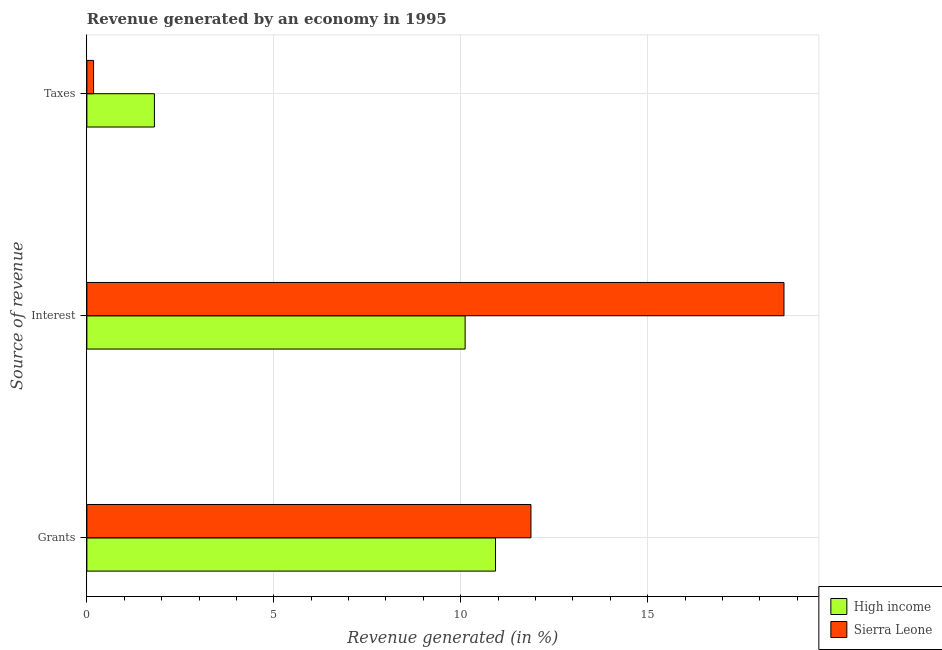How many bars are there on the 3rd tick from the bottom?
Provide a short and direct response. 2. What is the label of the 3rd group of bars from the top?
Provide a succinct answer. Grants. What is the percentage of revenue generated by taxes in High income?
Offer a very short reply. 1.81. Across all countries, what is the maximum percentage of revenue generated by taxes?
Provide a succinct answer. 1.81. Across all countries, what is the minimum percentage of revenue generated by grants?
Give a very brief answer. 10.93. In which country was the percentage of revenue generated by grants maximum?
Make the answer very short. Sierra Leone. In which country was the percentage of revenue generated by grants minimum?
Give a very brief answer. High income. What is the total percentage of revenue generated by taxes in the graph?
Ensure brevity in your answer.  1.99. What is the difference between the percentage of revenue generated by grants in High income and that in Sierra Leone?
Give a very brief answer. -0.95. What is the difference between the percentage of revenue generated by grants in High income and the percentage of revenue generated by interest in Sierra Leone?
Make the answer very short. -7.72. What is the average percentage of revenue generated by taxes per country?
Give a very brief answer. 0.99. What is the difference between the percentage of revenue generated by taxes and percentage of revenue generated by grants in Sierra Leone?
Provide a short and direct response. -11.7. What is the ratio of the percentage of revenue generated by interest in High income to that in Sierra Leone?
Make the answer very short. 0.54. What is the difference between the highest and the second highest percentage of revenue generated by taxes?
Offer a terse response. 1.63. What is the difference between the highest and the lowest percentage of revenue generated by grants?
Your answer should be very brief. 0.95. Is the sum of the percentage of revenue generated by grants in High income and Sierra Leone greater than the maximum percentage of revenue generated by interest across all countries?
Ensure brevity in your answer.  Yes. What does the 1st bar from the top in Grants represents?
Your response must be concise. Sierra Leone. Is it the case that in every country, the sum of the percentage of revenue generated by grants and percentage of revenue generated by interest is greater than the percentage of revenue generated by taxes?
Your answer should be very brief. Yes. How many bars are there?
Offer a very short reply. 6. Are all the bars in the graph horizontal?
Offer a very short reply. Yes. How many countries are there in the graph?
Keep it short and to the point. 2. Are the values on the major ticks of X-axis written in scientific E-notation?
Keep it short and to the point. No. Does the graph contain any zero values?
Your answer should be very brief. No. How many legend labels are there?
Your response must be concise. 2. What is the title of the graph?
Ensure brevity in your answer.  Revenue generated by an economy in 1995. Does "Liechtenstein" appear as one of the legend labels in the graph?
Provide a short and direct response. No. What is the label or title of the X-axis?
Your answer should be very brief. Revenue generated (in %). What is the label or title of the Y-axis?
Your answer should be very brief. Source of revenue. What is the Revenue generated (in %) of High income in Grants?
Make the answer very short. 10.93. What is the Revenue generated (in %) in Sierra Leone in Grants?
Your response must be concise. 11.88. What is the Revenue generated (in %) of High income in Interest?
Keep it short and to the point. 10.12. What is the Revenue generated (in %) of Sierra Leone in Interest?
Offer a very short reply. 18.65. What is the Revenue generated (in %) in High income in Taxes?
Make the answer very short. 1.81. What is the Revenue generated (in %) of Sierra Leone in Taxes?
Your response must be concise. 0.18. Across all Source of revenue, what is the maximum Revenue generated (in %) in High income?
Offer a very short reply. 10.93. Across all Source of revenue, what is the maximum Revenue generated (in %) in Sierra Leone?
Keep it short and to the point. 18.65. Across all Source of revenue, what is the minimum Revenue generated (in %) of High income?
Your answer should be compact. 1.81. Across all Source of revenue, what is the minimum Revenue generated (in %) in Sierra Leone?
Offer a very short reply. 0.18. What is the total Revenue generated (in %) in High income in the graph?
Your answer should be very brief. 22.85. What is the total Revenue generated (in %) in Sierra Leone in the graph?
Keep it short and to the point. 30.7. What is the difference between the Revenue generated (in %) in High income in Grants and that in Interest?
Ensure brevity in your answer.  0.81. What is the difference between the Revenue generated (in %) of Sierra Leone in Grants and that in Interest?
Offer a very short reply. -6.77. What is the difference between the Revenue generated (in %) of High income in Grants and that in Taxes?
Your answer should be compact. 9.12. What is the difference between the Revenue generated (in %) in Sierra Leone in Grants and that in Taxes?
Provide a succinct answer. 11.7. What is the difference between the Revenue generated (in %) in High income in Interest and that in Taxes?
Your response must be concise. 8.31. What is the difference between the Revenue generated (in %) in Sierra Leone in Interest and that in Taxes?
Offer a very short reply. 18.47. What is the difference between the Revenue generated (in %) in High income in Grants and the Revenue generated (in %) in Sierra Leone in Interest?
Your response must be concise. -7.72. What is the difference between the Revenue generated (in %) in High income in Grants and the Revenue generated (in %) in Sierra Leone in Taxes?
Keep it short and to the point. 10.75. What is the difference between the Revenue generated (in %) in High income in Interest and the Revenue generated (in %) in Sierra Leone in Taxes?
Make the answer very short. 9.94. What is the average Revenue generated (in %) in High income per Source of revenue?
Your answer should be very brief. 7.62. What is the average Revenue generated (in %) of Sierra Leone per Source of revenue?
Offer a terse response. 10.23. What is the difference between the Revenue generated (in %) of High income and Revenue generated (in %) of Sierra Leone in Grants?
Your response must be concise. -0.95. What is the difference between the Revenue generated (in %) in High income and Revenue generated (in %) in Sierra Leone in Interest?
Offer a very short reply. -8.53. What is the difference between the Revenue generated (in %) in High income and Revenue generated (in %) in Sierra Leone in Taxes?
Provide a short and direct response. 1.63. What is the ratio of the Revenue generated (in %) in High income in Grants to that in Interest?
Ensure brevity in your answer.  1.08. What is the ratio of the Revenue generated (in %) of Sierra Leone in Grants to that in Interest?
Make the answer very short. 0.64. What is the ratio of the Revenue generated (in %) in High income in Grants to that in Taxes?
Provide a succinct answer. 6.05. What is the ratio of the Revenue generated (in %) of Sierra Leone in Grants to that in Taxes?
Provide a short and direct response. 66.24. What is the ratio of the Revenue generated (in %) of High income in Interest to that in Taxes?
Offer a terse response. 5.6. What is the ratio of the Revenue generated (in %) in Sierra Leone in Interest to that in Taxes?
Keep it short and to the point. 103.98. What is the difference between the highest and the second highest Revenue generated (in %) of High income?
Provide a short and direct response. 0.81. What is the difference between the highest and the second highest Revenue generated (in %) of Sierra Leone?
Your response must be concise. 6.77. What is the difference between the highest and the lowest Revenue generated (in %) of High income?
Your answer should be very brief. 9.12. What is the difference between the highest and the lowest Revenue generated (in %) in Sierra Leone?
Provide a succinct answer. 18.47. 